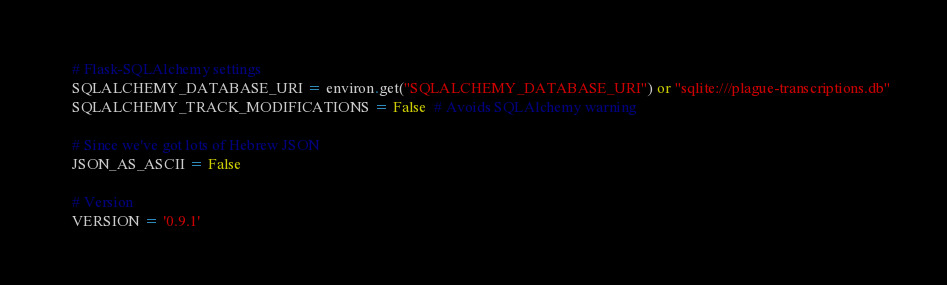<code> <loc_0><loc_0><loc_500><loc_500><_Python_>    # Flask-SQLAlchemy settings
    SQLALCHEMY_DATABASE_URI = environ.get("SQLALCHEMY_DATABASE_URI") or "sqlite:///plague-transcriptions.db"
    SQLALCHEMY_TRACK_MODIFICATIONS = False  # Avoids SQLAlchemy warning

    # Since we've got lots of Hebrew JSON
    JSON_AS_ASCII = False

    # Version
    VERSION = '0.9.1'
</code> 